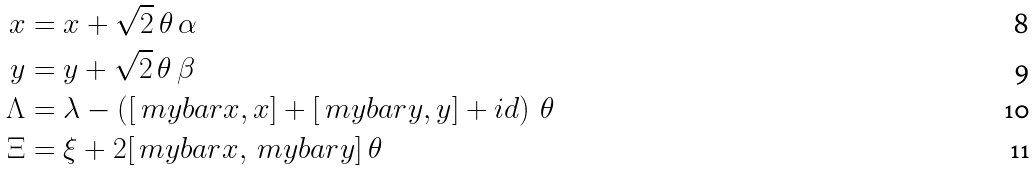Convert formula to latex. <formula><loc_0><loc_0><loc_500><loc_500>x & = x + \sqrt { 2 } \, \theta \, \alpha \\ y & = y + \sqrt { 2 } \, \theta \, \beta \\ \Lambda & = \lambda - \left ( [ \ m y b a r x , x ] + [ \ m y b a r y , y ] + i d \right ) \, \theta \\ \Xi & = \xi + 2 [ \ m y b a r x , \ m y b a r y ] \, \theta</formula> 